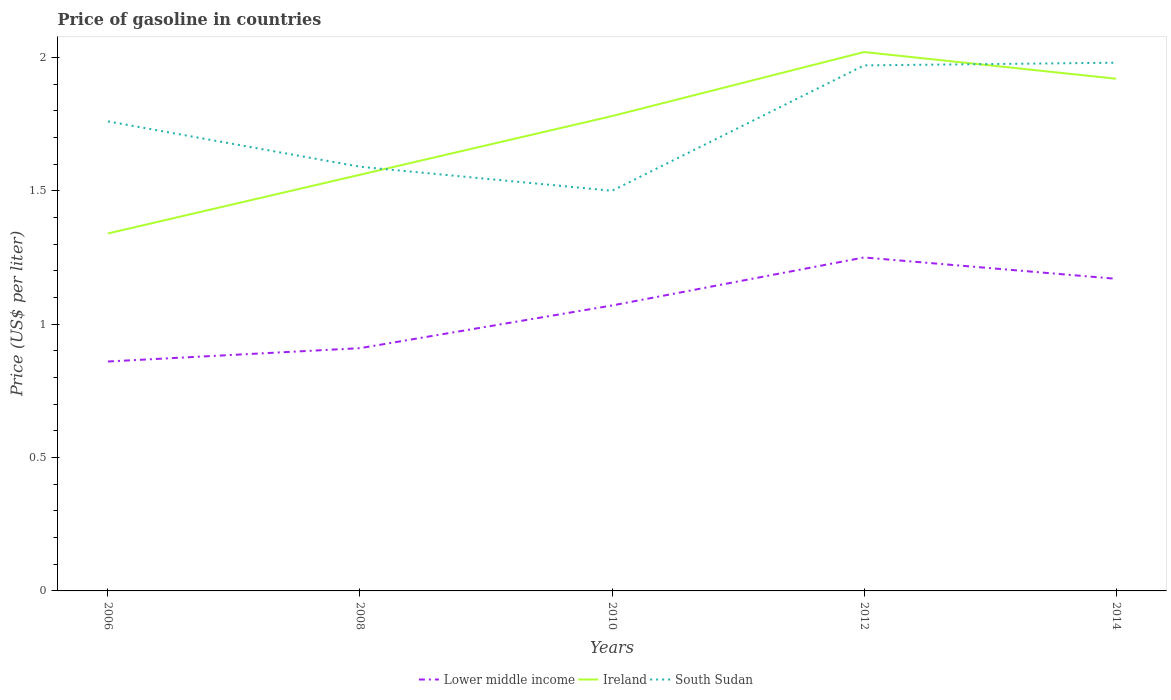Is the number of lines equal to the number of legend labels?
Give a very brief answer. Yes. Across all years, what is the maximum price of gasoline in Ireland?
Offer a very short reply. 1.34. In which year was the price of gasoline in Lower middle income maximum?
Provide a succinct answer. 2006. What is the total price of gasoline in South Sudan in the graph?
Offer a very short reply. -0.01. What is the difference between the highest and the second highest price of gasoline in Ireland?
Make the answer very short. 0.68. What is the difference between the highest and the lowest price of gasoline in South Sudan?
Your answer should be compact. 3. Is the price of gasoline in South Sudan strictly greater than the price of gasoline in Lower middle income over the years?
Provide a short and direct response. No. How many years are there in the graph?
Your answer should be very brief. 5. Are the values on the major ticks of Y-axis written in scientific E-notation?
Your response must be concise. No. Does the graph contain any zero values?
Keep it short and to the point. No. Does the graph contain grids?
Your response must be concise. No. Where does the legend appear in the graph?
Give a very brief answer. Bottom center. What is the title of the graph?
Give a very brief answer. Price of gasoline in countries. What is the label or title of the Y-axis?
Provide a short and direct response. Price (US$ per liter). What is the Price (US$ per liter) in Lower middle income in 2006?
Offer a terse response. 0.86. What is the Price (US$ per liter) of Ireland in 2006?
Keep it short and to the point. 1.34. What is the Price (US$ per liter) in South Sudan in 2006?
Provide a succinct answer. 1.76. What is the Price (US$ per liter) of Lower middle income in 2008?
Make the answer very short. 0.91. What is the Price (US$ per liter) in Ireland in 2008?
Provide a succinct answer. 1.56. What is the Price (US$ per liter) in South Sudan in 2008?
Make the answer very short. 1.59. What is the Price (US$ per liter) in Lower middle income in 2010?
Provide a succinct answer. 1.07. What is the Price (US$ per liter) of Ireland in 2010?
Offer a terse response. 1.78. What is the Price (US$ per liter) of Ireland in 2012?
Your response must be concise. 2.02. What is the Price (US$ per liter) in South Sudan in 2012?
Ensure brevity in your answer.  1.97. What is the Price (US$ per liter) of Lower middle income in 2014?
Your response must be concise. 1.17. What is the Price (US$ per liter) of Ireland in 2014?
Give a very brief answer. 1.92. What is the Price (US$ per liter) of South Sudan in 2014?
Provide a short and direct response. 1.98. Across all years, what is the maximum Price (US$ per liter) in Ireland?
Your response must be concise. 2.02. Across all years, what is the maximum Price (US$ per liter) of South Sudan?
Ensure brevity in your answer.  1.98. Across all years, what is the minimum Price (US$ per liter) of Lower middle income?
Make the answer very short. 0.86. Across all years, what is the minimum Price (US$ per liter) of Ireland?
Provide a succinct answer. 1.34. Across all years, what is the minimum Price (US$ per liter) in South Sudan?
Offer a very short reply. 1.5. What is the total Price (US$ per liter) in Lower middle income in the graph?
Give a very brief answer. 5.26. What is the total Price (US$ per liter) of Ireland in the graph?
Provide a short and direct response. 8.62. What is the difference between the Price (US$ per liter) of Ireland in 2006 and that in 2008?
Your answer should be compact. -0.22. What is the difference between the Price (US$ per liter) in South Sudan in 2006 and that in 2008?
Keep it short and to the point. 0.17. What is the difference between the Price (US$ per liter) in Lower middle income in 2006 and that in 2010?
Your response must be concise. -0.21. What is the difference between the Price (US$ per liter) in Ireland in 2006 and that in 2010?
Your answer should be compact. -0.44. What is the difference between the Price (US$ per liter) in South Sudan in 2006 and that in 2010?
Offer a terse response. 0.26. What is the difference between the Price (US$ per liter) in Lower middle income in 2006 and that in 2012?
Make the answer very short. -0.39. What is the difference between the Price (US$ per liter) of Ireland in 2006 and that in 2012?
Your answer should be very brief. -0.68. What is the difference between the Price (US$ per liter) of South Sudan in 2006 and that in 2012?
Keep it short and to the point. -0.21. What is the difference between the Price (US$ per liter) in Lower middle income in 2006 and that in 2014?
Offer a terse response. -0.31. What is the difference between the Price (US$ per liter) of Ireland in 2006 and that in 2014?
Give a very brief answer. -0.58. What is the difference between the Price (US$ per liter) of South Sudan in 2006 and that in 2014?
Offer a terse response. -0.22. What is the difference between the Price (US$ per liter) in Lower middle income in 2008 and that in 2010?
Provide a short and direct response. -0.16. What is the difference between the Price (US$ per liter) of Ireland in 2008 and that in 2010?
Make the answer very short. -0.22. What is the difference between the Price (US$ per liter) of South Sudan in 2008 and that in 2010?
Ensure brevity in your answer.  0.09. What is the difference between the Price (US$ per liter) of Lower middle income in 2008 and that in 2012?
Offer a very short reply. -0.34. What is the difference between the Price (US$ per liter) of Ireland in 2008 and that in 2012?
Give a very brief answer. -0.46. What is the difference between the Price (US$ per liter) of South Sudan in 2008 and that in 2012?
Your answer should be very brief. -0.38. What is the difference between the Price (US$ per liter) of Lower middle income in 2008 and that in 2014?
Make the answer very short. -0.26. What is the difference between the Price (US$ per liter) in Ireland in 2008 and that in 2014?
Give a very brief answer. -0.36. What is the difference between the Price (US$ per liter) in South Sudan in 2008 and that in 2014?
Keep it short and to the point. -0.39. What is the difference between the Price (US$ per liter) in Lower middle income in 2010 and that in 2012?
Offer a terse response. -0.18. What is the difference between the Price (US$ per liter) of Ireland in 2010 and that in 2012?
Offer a very short reply. -0.24. What is the difference between the Price (US$ per liter) of South Sudan in 2010 and that in 2012?
Offer a very short reply. -0.47. What is the difference between the Price (US$ per liter) of Lower middle income in 2010 and that in 2014?
Provide a short and direct response. -0.1. What is the difference between the Price (US$ per liter) in Ireland in 2010 and that in 2014?
Provide a succinct answer. -0.14. What is the difference between the Price (US$ per liter) in South Sudan in 2010 and that in 2014?
Your response must be concise. -0.48. What is the difference between the Price (US$ per liter) in Lower middle income in 2012 and that in 2014?
Make the answer very short. 0.08. What is the difference between the Price (US$ per liter) of South Sudan in 2012 and that in 2014?
Provide a short and direct response. -0.01. What is the difference between the Price (US$ per liter) in Lower middle income in 2006 and the Price (US$ per liter) in South Sudan in 2008?
Your answer should be very brief. -0.73. What is the difference between the Price (US$ per liter) of Ireland in 2006 and the Price (US$ per liter) of South Sudan in 2008?
Ensure brevity in your answer.  -0.25. What is the difference between the Price (US$ per liter) of Lower middle income in 2006 and the Price (US$ per liter) of Ireland in 2010?
Provide a succinct answer. -0.92. What is the difference between the Price (US$ per liter) in Lower middle income in 2006 and the Price (US$ per liter) in South Sudan in 2010?
Ensure brevity in your answer.  -0.64. What is the difference between the Price (US$ per liter) of Ireland in 2006 and the Price (US$ per liter) of South Sudan in 2010?
Provide a short and direct response. -0.16. What is the difference between the Price (US$ per liter) in Lower middle income in 2006 and the Price (US$ per liter) in Ireland in 2012?
Make the answer very short. -1.16. What is the difference between the Price (US$ per liter) in Lower middle income in 2006 and the Price (US$ per liter) in South Sudan in 2012?
Your answer should be very brief. -1.11. What is the difference between the Price (US$ per liter) in Ireland in 2006 and the Price (US$ per liter) in South Sudan in 2012?
Your answer should be compact. -0.63. What is the difference between the Price (US$ per liter) in Lower middle income in 2006 and the Price (US$ per liter) in Ireland in 2014?
Provide a succinct answer. -1.06. What is the difference between the Price (US$ per liter) in Lower middle income in 2006 and the Price (US$ per liter) in South Sudan in 2014?
Make the answer very short. -1.12. What is the difference between the Price (US$ per liter) in Ireland in 2006 and the Price (US$ per liter) in South Sudan in 2014?
Offer a terse response. -0.64. What is the difference between the Price (US$ per liter) of Lower middle income in 2008 and the Price (US$ per liter) of Ireland in 2010?
Provide a succinct answer. -0.87. What is the difference between the Price (US$ per liter) in Lower middle income in 2008 and the Price (US$ per liter) in South Sudan in 2010?
Make the answer very short. -0.59. What is the difference between the Price (US$ per liter) in Ireland in 2008 and the Price (US$ per liter) in South Sudan in 2010?
Your answer should be compact. 0.06. What is the difference between the Price (US$ per liter) in Lower middle income in 2008 and the Price (US$ per liter) in Ireland in 2012?
Provide a short and direct response. -1.11. What is the difference between the Price (US$ per liter) of Lower middle income in 2008 and the Price (US$ per liter) of South Sudan in 2012?
Your answer should be compact. -1.06. What is the difference between the Price (US$ per liter) of Ireland in 2008 and the Price (US$ per liter) of South Sudan in 2012?
Your answer should be very brief. -0.41. What is the difference between the Price (US$ per liter) of Lower middle income in 2008 and the Price (US$ per liter) of Ireland in 2014?
Your response must be concise. -1.01. What is the difference between the Price (US$ per liter) in Lower middle income in 2008 and the Price (US$ per liter) in South Sudan in 2014?
Keep it short and to the point. -1.07. What is the difference between the Price (US$ per liter) of Ireland in 2008 and the Price (US$ per liter) of South Sudan in 2014?
Keep it short and to the point. -0.42. What is the difference between the Price (US$ per liter) of Lower middle income in 2010 and the Price (US$ per liter) of Ireland in 2012?
Give a very brief answer. -0.95. What is the difference between the Price (US$ per liter) of Lower middle income in 2010 and the Price (US$ per liter) of South Sudan in 2012?
Offer a terse response. -0.9. What is the difference between the Price (US$ per liter) of Ireland in 2010 and the Price (US$ per liter) of South Sudan in 2012?
Ensure brevity in your answer.  -0.19. What is the difference between the Price (US$ per liter) in Lower middle income in 2010 and the Price (US$ per liter) in Ireland in 2014?
Your answer should be very brief. -0.85. What is the difference between the Price (US$ per liter) of Lower middle income in 2010 and the Price (US$ per liter) of South Sudan in 2014?
Offer a very short reply. -0.91. What is the difference between the Price (US$ per liter) of Ireland in 2010 and the Price (US$ per liter) of South Sudan in 2014?
Your answer should be compact. -0.2. What is the difference between the Price (US$ per liter) in Lower middle income in 2012 and the Price (US$ per liter) in Ireland in 2014?
Provide a succinct answer. -0.67. What is the difference between the Price (US$ per liter) of Lower middle income in 2012 and the Price (US$ per liter) of South Sudan in 2014?
Make the answer very short. -0.73. What is the average Price (US$ per liter) of Lower middle income per year?
Give a very brief answer. 1.05. What is the average Price (US$ per liter) in Ireland per year?
Your answer should be very brief. 1.72. What is the average Price (US$ per liter) in South Sudan per year?
Offer a terse response. 1.76. In the year 2006, what is the difference between the Price (US$ per liter) of Lower middle income and Price (US$ per liter) of Ireland?
Provide a short and direct response. -0.48. In the year 2006, what is the difference between the Price (US$ per liter) of Lower middle income and Price (US$ per liter) of South Sudan?
Your answer should be compact. -0.9. In the year 2006, what is the difference between the Price (US$ per liter) of Ireland and Price (US$ per liter) of South Sudan?
Make the answer very short. -0.42. In the year 2008, what is the difference between the Price (US$ per liter) in Lower middle income and Price (US$ per liter) in Ireland?
Your answer should be very brief. -0.65. In the year 2008, what is the difference between the Price (US$ per liter) of Lower middle income and Price (US$ per liter) of South Sudan?
Provide a short and direct response. -0.68. In the year 2008, what is the difference between the Price (US$ per liter) in Ireland and Price (US$ per liter) in South Sudan?
Your response must be concise. -0.03. In the year 2010, what is the difference between the Price (US$ per liter) in Lower middle income and Price (US$ per liter) in Ireland?
Provide a succinct answer. -0.71. In the year 2010, what is the difference between the Price (US$ per liter) of Lower middle income and Price (US$ per liter) of South Sudan?
Your answer should be very brief. -0.43. In the year 2010, what is the difference between the Price (US$ per liter) of Ireland and Price (US$ per liter) of South Sudan?
Your answer should be compact. 0.28. In the year 2012, what is the difference between the Price (US$ per liter) in Lower middle income and Price (US$ per liter) in Ireland?
Your response must be concise. -0.77. In the year 2012, what is the difference between the Price (US$ per liter) in Lower middle income and Price (US$ per liter) in South Sudan?
Provide a short and direct response. -0.72. In the year 2012, what is the difference between the Price (US$ per liter) in Ireland and Price (US$ per liter) in South Sudan?
Your answer should be very brief. 0.05. In the year 2014, what is the difference between the Price (US$ per liter) in Lower middle income and Price (US$ per liter) in Ireland?
Your response must be concise. -0.75. In the year 2014, what is the difference between the Price (US$ per liter) in Lower middle income and Price (US$ per liter) in South Sudan?
Ensure brevity in your answer.  -0.81. In the year 2014, what is the difference between the Price (US$ per liter) in Ireland and Price (US$ per liter) in South Sudan?
Ensure brevity in your answer.  -0.06. What is the ratio of the Price (US$ per liter) in Lower middle income in 2006 to that in 2008?
Make the answer very short. 0.95. What is the ratio of the Price (US$ per liter) in Ireland in 2006 to that in 2008?
Your answer should be compact. 0.86. What is the ratio of the Price (US$ per liter) of South Sudan in 2006 to that in 2008?
Keep it short and to the point. 1.11. What is the ratio of the Price (US$ per liter) in Lower middle income in 2006 to that in 2010?
Your answer should be compact. 0.8. What is the ratio of the Price (US$ per liter) of Ireland in 2006 to that in 2010?
Offer a terse response. 0.75. What is the ratio of the Price (US$ per liter) in South Sudan in 2006 to that in 2010?
Ensure brevity in your answer.  1.17. What is the ratio of the Price (US$ per liter) of Lower middle income in 2006 to that in 2012?
Provide a succinct answer. 0.69. What is the ratio of the Price (US$ per liter) in Ireland in 2006 to that in 2012?
Keep it short and to the point. 0.66. What is the ratio of the Price (US$ per liter) in South Sudan in 2006 to that in 2012?
Provide a succinct answer. 0.89. What is the ratio of the Price (US$ per liter) in Lower middle income in 2006 to that in 2014?
Ensure brevity in your answer.  0.73. What is the ratio of the Price (US$ per liter) in Ireland in 2006 to that in 2014?
Keep it short and to the point. 0.7. What is the ratio of the Price (US$ per liter) in South Sudan in 2006 to that in 2014?
Your response must be concise. 0.89. What is the ratio of the Price (US$ per liter) in Lower middle income in 2008 to that in 2010?
Provide a short and direct response. 0.85. What is the ratio of the Price (US$ per liter) of Ireland in 2008 to that in 2010?
Offer a very short reply. 0.88. What is the ratio of the Price (US$ per liter) in South Sudan in 2008 to that in 2010?
Provide a succinct answer. 1.06. What is the ratio of the Price (US$ per liter) in Lower middle income in 2008 to that in 2012?
Offer a very short reply. 0.73. What is the ratio of the Price (US$ per liter) of Ireland in 2008 to that in 2012?
Offer a very short reply. 0.77. What is the ratio of the Price (US$ per liter) in South Sudan in 2008 to that in 2012?
Give a very brief answer. 0.81. What is the ratio of the Price (US$ per liter) of Lower middle income in 2008 to that in 2014?
Your answer should be compact. 0.78. What is the ratio of the Price (US$ per liter) of Ireland in 2008 to that in 2014?
Your answer should be very brief. 0.81. What is the ratio of the Price (US$ per liter) of South Sudan in 2008 to that in 2014?
Make the answer very short. 0.8. What is the ratio of the Price (US$ per liter) of Lower middle income in 2010 to that in 2012?
Keep it short and to the point. 0.86. What is the ratio of the Price (US$ per liter) of Ireland in 2010 to that in 2012?
Your response must be concise. 0.88. What is the ratio of the Price (US$ per liter) in South Sudan in 2010 to that in 2012?
Make the answer very short. 0.76. What is the ratio of the Price (US$ per liter) in Lower middle income in 2010 to that in 2014?
Ensure brevity in your answer.  0.91. What is the ratio of the Price (US$ per liter) of Ireland in 2010 to that in 2014?
Provide a succinct answer. 0.93. What is the ratio of the Price (US$ per liter) in South Sudan in 2010 to that in 2014?
Ensure brevity in your answer.  0.76. What is the ratio of the Price (US$ per liter) in Lower middle income in 2012 to that in 2014?
Provide a short and direct response. 1.07. What is the ratio of the Price (US$ per liter) of Ireland in 2012 to that in 2014?
Your answer should be compact. 1.05. What is the difference between the highest and the lowest Price (US$ per liter) of Lower middle income?
Make the answer very short. 0.39. What is the difference between the highest and the lowest Price (US$ per liter) in Ireland?
Offer a terse response. 0.68. What is the difference between the highest and the lowest Price (US$ per liter) in South Sudan?
Give a very brief answer. 0.48. 